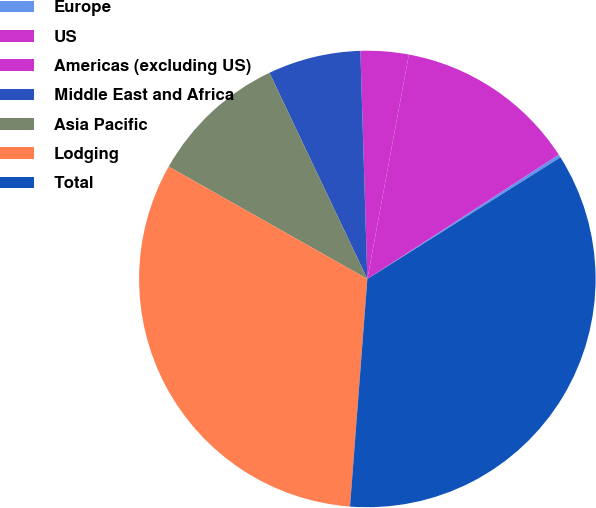<chart> <loc_0><loc_0><loc_500><loc_500><pie_chart><fcel>Europe<fcel>US<fcel>Americas (excluding US)<fcel>Middle East and Africa<fcel>Asia Pacific<fcel>Lodging<fcel>Total<nl><fcel>0.22%<fcel>12.92%<fcel>3.4%<fcel>6.57%<fcel>9.75%<fcel>31.98%<fcel>35.15%<nl></chart> 